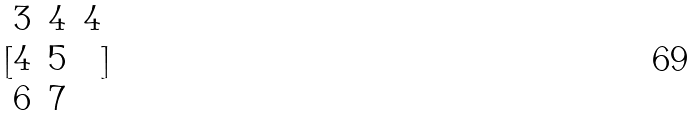Convert formula to latex. <formula><loc_0><loc_0><loc_500><loc_500>[ \begin{matrix} 3 & 4 & 4 \\ 4 & 5 \\ 6 & 7 \end{matrix} ]</formula> 